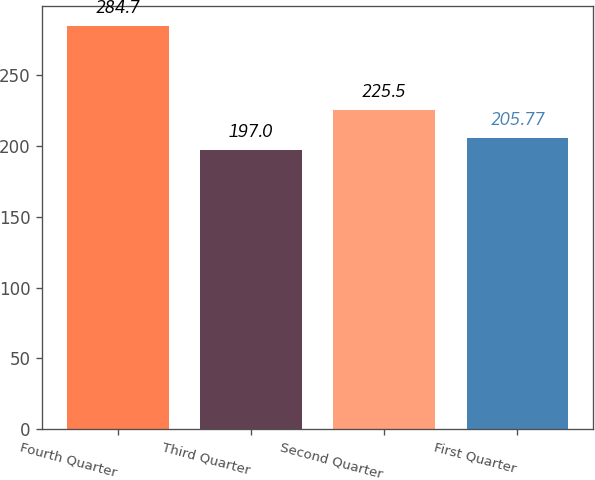Convert chart. <chart><loc_0><loc_0><loc_500><loc_500><bar_chart><fcel>Fourth Quarter<fcel>Third Quarter<fcel>Second Quarter<fcel>First Quarter<nl><fcel>284.7<fcel>197<fcel>225.5<fcel>205.77<nl></chart> 